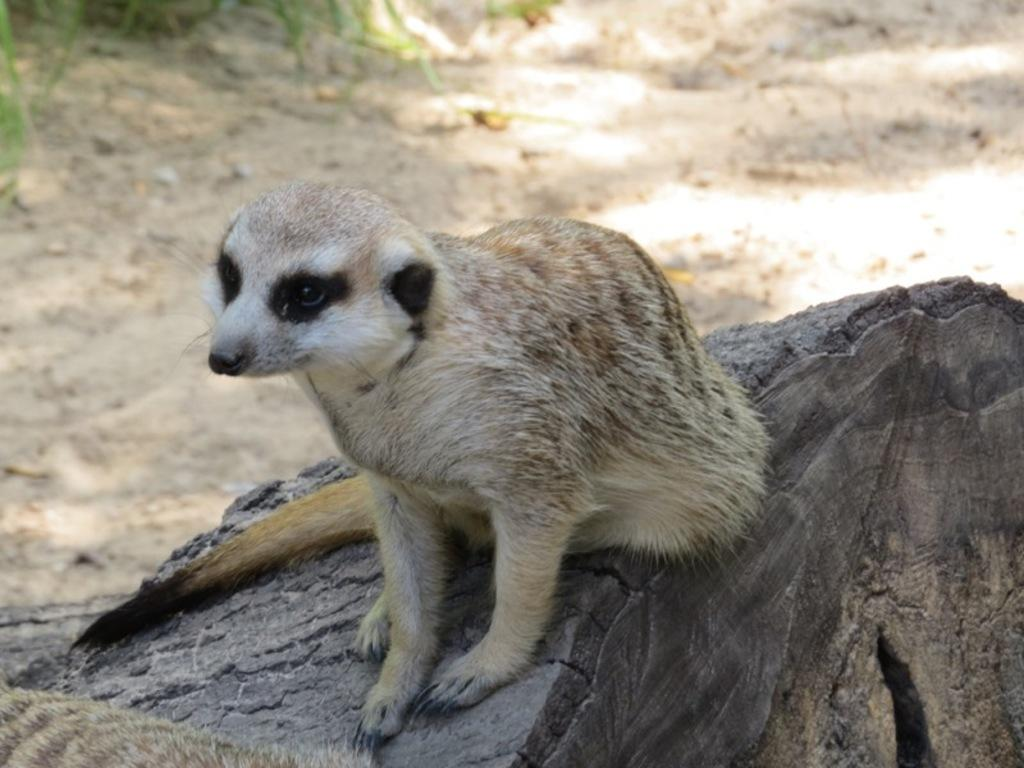What type of animal is in the image? The type of animal cannot be determined from the provided facts. Where is the animal located in the image? The animal is on a trunk in the image. What can be seen in the background of the image? There is grass visible in the background of the image. How many fingers can be seen on the animal's hand in the image? There are no fingers visible on the animal's hand in the image, as the animal's hand is not shown. 